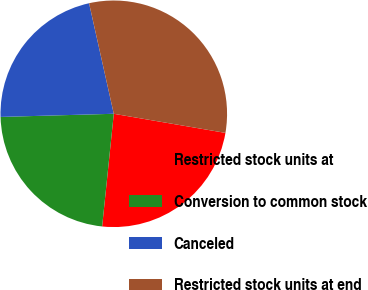Convert chart to OTSL. <chart><loc_0><loc_0><loc_500><loc_500><pie_chart><fcel>Restricted stock units at<fcel>Conversion to common stock<fcel>Canceled<fcel>Restricted stock units at end<nl><fcel>23.94%<fcel>22.92%<fcel>21.94%<fcel>31.2%<nl></chart> 